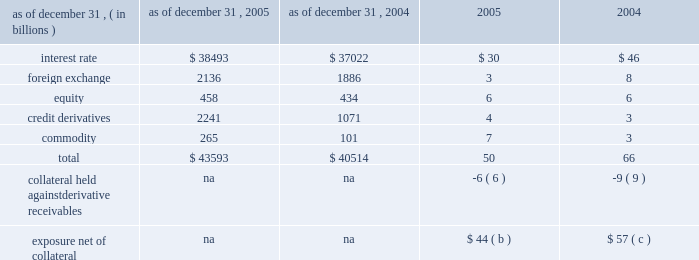Notional amounts and derivative receivables marked to market ( 201cmtm 201d ) notional amounts ( a ) derivative receivables mtm as of december 31 .
( a ) the notional amounts represent the gross sum of long and short third-party notional derivative contracts , excluding written options and foreign exchange spot contracts , which significantly exceed the possible credit losses that could arise from such transactions .
For most derivative transactions , the notional principal amount does not change hands ; it is used simply as a reference to calculate payments .
( b ) the firm held $ 33 billion of collateral against derivative receivables as of december 31 , 2005 , consisting of $ 27 billion in net cash received under credit support annexes to legally enforceable master netting agreements , and $ 6 billion of other liquid securities collateral .
The benefit of the $ 27 billion is reflected within the $ 50 billion of derivative receivables mtm .
Excluded from the $ 33 billion of collateral is $ 10 billion of collateral delivered by clients at the initiation of transactions ; this collateral secures exposure that could arise in the derivatives portfolio should the mtm of the client 2019s transactions move in the firm 2019s favor .
Also excluded are credit enhancements in the form of letters of credit and surety receivables .
( c ) the firm held $ 41 billion of collateral against derivative receivables as of december 31 , 2004 , consisting of $ 32 billion in net cash received under credit support annexes to legally enforceable master netting agreements , and $ 9 billion of other liquid securities collateral .
The benefit of the $ 32 billion is reflected within the $ 66 billion of derivative receivables mtm .
Excluded from the $ 41 billion of collateral is $ 10 billion of collateral delivered by clients at the initiation of transactions ; this collateral secures exposure that could arise in the derivatives portfolio should the mtm of the client 2019s transactions move in the firm 2019s favor .
Also excluded are credit enhancements in the form of letters of credit and surety receivables .
Management 2019s discussion and analysis jpmorgan chase & co .
68 jpmorgan chase & co .
/ 2005 annual report 1 year 2 years 5 years 10 years mdp avgavgdredre exposure profile of derivatives measures december 31 , 2005 ( in billions ) the following table summarizes the aggregate notional amounts and the reported derivative receivables ( i.e. , the mtm or fair value of the derivative contracts after taking into account the effects of legally enforceable master netting agreements ) at each of the dates indicated : the mtm of derivative receivables contracts represents the cost to replace the contracts at current market rates should the counterparty default .
When jpmorgan chase has more than one transaction outstanding with a counter- party , and a legally enforceable master netting agreement exists with that counterparty , the netted mtm exposure , less collateral held , represents , in the firm 2019s view , the appropriate measure of current credit risk .
While useful as a current view of credit exposure , the net mtm value of the derivative receivables does not capture the potential future variability of that credit exposure .
To capture the potential future variability of credit exposure , the firm calculates , on a client-by-client basis , three measures of potential derivatives-related credit loss : peak , derivative risk equivalent ( 201cdre 201d ) and average exposure ( 201cavg 201d ) .
These measures all incorporate netting and collateral benefits , where applicable .
Peak exposure to a counterparty is an extreme measure of exposure calculated at a 97.5% ( 97.5 % ) confidence level .
However , the total potential future credit risk embedded in the firm 2019s derivatives portfolio is not the simple sum of all peak client credit risks .
This is because , at the portfolio level , credit risk is reduced by the fact that when offsetting transactions are done with separate counter- parties , only one of the two trades can generate a credit loss , even if both counterparties were to default simultaneously .
The firm refers to this effect as market diversification , and the market-diversified peak ( 201cmdp 201d ) measure is a portfolio aggregation of counterparty peak measures , representing the maximum losses at the 97.5% ( 97.5 % ) confidence level that would occur if all coun- terparties defaulted under any one given market scenario and time frame .
Derivative risk equivalent ( 201cdre 201d ) exposure is a measure that expresses the riskiness of derivative exposure on a basis intended to be equivalent to the riskiness of loan exposures .
The measurement is done by equating the unexpected loss in a derivative counterparty exposure ( which takes into consideration both the loss volatility and the credit rating of the counterparty ) with the unexpected loss in a loan exposure ( which takes into consideration only the credit rating of the counterparty ) .
Dre is a less extreme measure of potential credit loss than peak and is the primary measure used by the firm for credit approval of derivative transactions .
Finally , average exposure ( 201cavg 201d ) is a measure of the expected mtm value of the firm 2019s derivative receivables at future time periods , including the benefit of collateral .
Avg exposure over the total life of the derivative contract is used as the primary metric for pricing purposes and is used to calculate credit capital and the credit valuation adjustment ( 201ccva 201d ) , as further described below .
Average exposure was $ 36 billion and $ 38 billion at december 31 , 2005 and 2004 , respectively , compared with derivative receivables mtm net of other highly liquid collateral of $ 44 billion and $ 57 billion at december 31 , 2005 and 2004 , respectively .
The graph below shows exposure profiles to derivatives over the next 10 years as calculated by the mdp , dre and avg metrics .
All three measures generally show declining exposure after the first year , if no new trades were added to the portfolio. .
Without credit derivatives , what would 2005 total derivatives balance have been , in us$ b? 
Computations: (43593 - 2241)
Answer: 41352.0. 